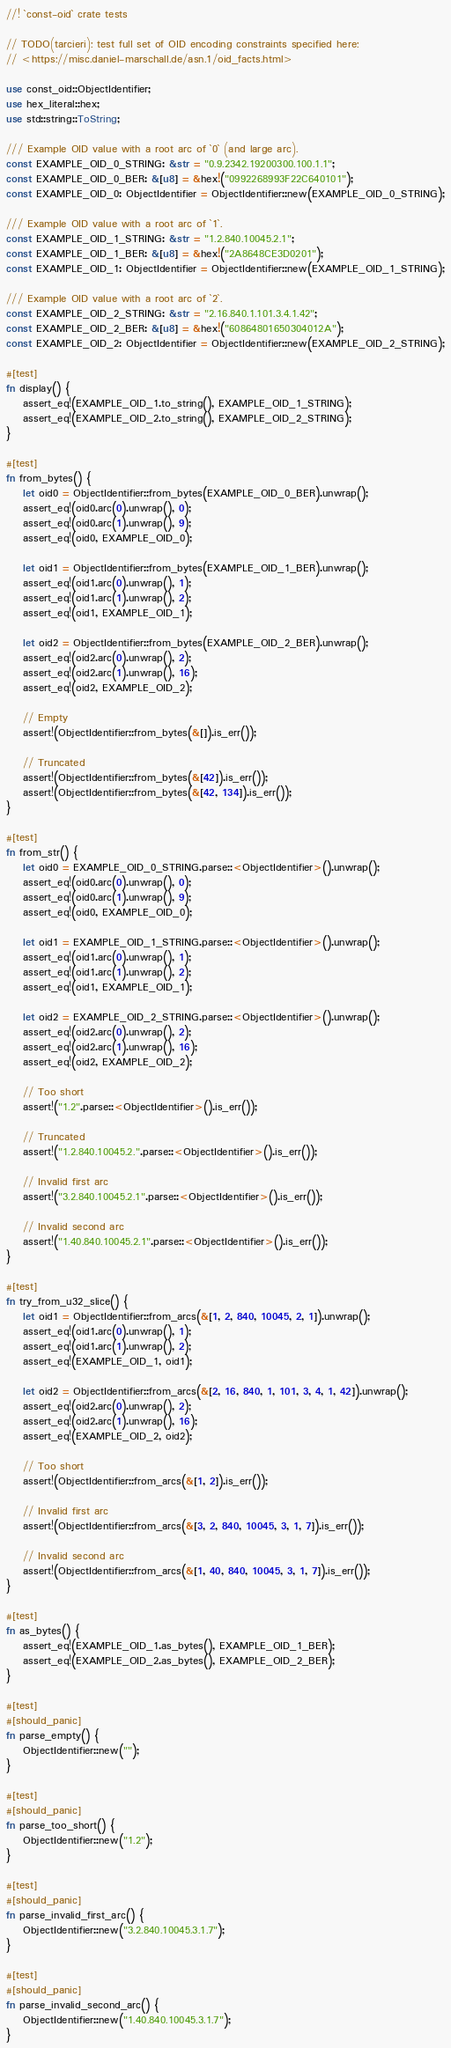<code> <loc_0><loc_0><loc_500><loc_500><_Rust_>//! `const-oid` crate tests

// TODO(tarcieri): test full set of OID encoding constraints specified here:
// <https://misc.daniel-marschall.de/asn.1/oid_facts.html>

use const_oid::ObjectIdentifier;
use hex_literal::hex;
use std::string::ToString;

/// Example OID value with a root arc of `0` (and large arc).
const EXAMPLE_OID_0_STRING: &str = "0.9.2342.19200300.100.1.1";
const EXAMPLE_OID_0_BER: &[u8] = &hex!("0992268993F22C640101");
const EXAMPLE_OID_0: ObjectIdentifier = ObjectIdentifier::new(EXAMPLE_OID_0_STRING);

/// Example OID value with a root arc of `1`.
const EXAMPLE_OID_1_STRING: &str = "1.2.840.10045.2.1";
const EXAMPLE_OID_1_BER: &[u8] = &hex!("2A8648CE3D0201");
const EXAMPLE_OID_1: ObjectIdentifier = ObjectIdentifier::new(EXAMPLE_OID_1_STRING);

/// Example OID value with a root arc of `2`.
const EXAMPLE_OID_2_STRING: &str = "2.16.840.1.101.3.4.1.42";
const EXAMPLE_OID_2_BER: &[u8] = &hex!("60864801650304012A");
const EXAMPLE_OID_2: ObjectIdentifier = ObjectIdentifier::new(EXAMPLE_OID_2_STRING);

#[test]
fn display() {
    assert_eq!(EXAMPLE_OID_1.to_string(), EXAMPLE_OID_1_STRING);
    assert_eq!(EXAMPLE_OID_2.to_string(), EXAMPLE_OID_2_STRING);
}

#[test]
fn from_bytes() {
    let oid0 = ObjectIdentifier::from_bytes(EXAMPLE_OID_0_BER).unwrap();
    assert_eq!(oid0.arc(0).unwrap(), 0);
    assert_eq!(oid0.arc(1).unwrap(), 9);
    assert_eq!(oid0, EXAMPLE_OID_0);

    let oid1 = ObjectIdentifier::from_bytes(EXAMPLE_OID_1_BER).unwrap();
    assert_eq!(oid1.arc(0).unwrap(), 1);
    assert_eq!(oid1.arc(1).unwrap(), 2);
    assert_eq!(oid1, EXAMPLE_OID_1);

    let oid2 = ObjectIdentifier::from_bytes(EXAMPLE_OID_2_BER).unwrap();
    assert_eq!(oid2.arc(0).unwrap(), 2);
    assert_eq!(oid2.arc(1).unwrap(), 16);
    assert_eq!(oid2, EXAMPLE_OID_2);

    // Empty
    assert!(ObjectIdentifier::from_bytes(&[]).is_err());

    // Truncated
    assert!(ObjectIdentifier::from_bytes(&[42]).is_err());
    assert!(ObjectIdentifier::from_bytes(&[42, 134]).is_err());
}

#[test]
fn from_str() {
    let oid0 = EXAMPLE_OID_0_STRING.parse::<ObjectIdentifier>().unwrap();
    assert_eq!(oid0.arc(0).unwrap(), 0);
    assert_eq!(oid0.arc(1).unwrap(), 9);
    assert_eq!(oid0, EXAMPLE_OID_0);

    let oid1 = EXAMPLE_OID_1_STRING.parse::<ObjectIdentifier>().unwrap();
    assert_eq!(oid1.arc(0).unwrap(), 1);
    assert_eq!(oid1.arc(1).unwrap(), 2);
    assert_eq!(oid1, EXAMPLE_OID_1);

    let oid2 = EXAMPLE_OID_2_STRING.parse::<ObjectIdentifier>().unwrap();
    assert_eq!(oid2.arc(0).unwrap(), 2);
    assert_eq!(oid2.arc(1).unwrap(), 16);
    assert_eq!(oid2, EXAMPLE_OID_2);

    // Too short
    assert!("1.2".parse::<ObjectIdentifier>().is_err());

    // Truncated
    assert!("1.2.840.10045.2.".parse::<ObjectIdentifier>().is_err());

    // Invalid first arc
    assert!("3.2.840.10045.2.1".parse::<ObjectIdentifier>().is_err());

    // Invalid second arc
    assert!("1.40.840.10045.2.1".parse::<ObjectIdentifier>().is_err());
}

#[test]
fn try_from_u32_slice() {
    let oid1 = ObjectIdentifier::from_arcs(&[1, 2, 840, 10045, 2, 1]).unwrap();
    assert_eq!(oid1.arc(0).unwrap(), 1);
    assert_eq!(oid1.arc(1).unwrap(), 2);
    assert_eq!(EXAMPLE_OID_1, oid1);

    let oid2 = ObjectIdentifier::from_arcs(&[2, 16, 840, 1, 101, 3, 4, 1, 42]).unwrap();
    assert_eq!(oid2.arc(0).unwrap(), 2);
    assert_eq!(oid2.arc(1).unwrap(), 16);
    assert_eq!(EXAMPLE_OID_2, oid2);

    // Too short
    assert!(ObjectIdentifier::from_arcs(&[1, 2]).is_err());

    // Invalid first arc
    assert!(ObjectIdentifier::from_arcs(&[3, 2, 840, 10045, 3, 1, 7]).is_err());

    // Invalid second arc
    assert!(ObjectIdentifier::from_arcs(&[1, 40, 840, 10045, 3, 1, 7]).is_err());
}

#[test]
fn as_bytes() {
    assert_eq!(EXAMPLE_OID_1.as_bytes(), EXAMPLE_OID_1_BER);
    assert_eq!(EXAMPLE_OID_2.as_bytes(), EXAMPLE_OID_2_BER);
}

#[test]
#[should_panic]
fn parse_empty() {
    ObjectIdentifier::new("");
}

#[test]
#[should_panic]
fn parse_too_short() {
    ObjectIdentifier::new("1.2");
}

#[test]
#[should_panic]
fn parse_invalid_first_arc() {
    ObjectIdentifier::new("3.2.840.10045.3.1.7");
}

#[test]
#[should_panic]
fn parse_invalid_second_arc() {
    ObjectIdentifier::new("1.40.840.10045.3.1.7");
}
</code> 